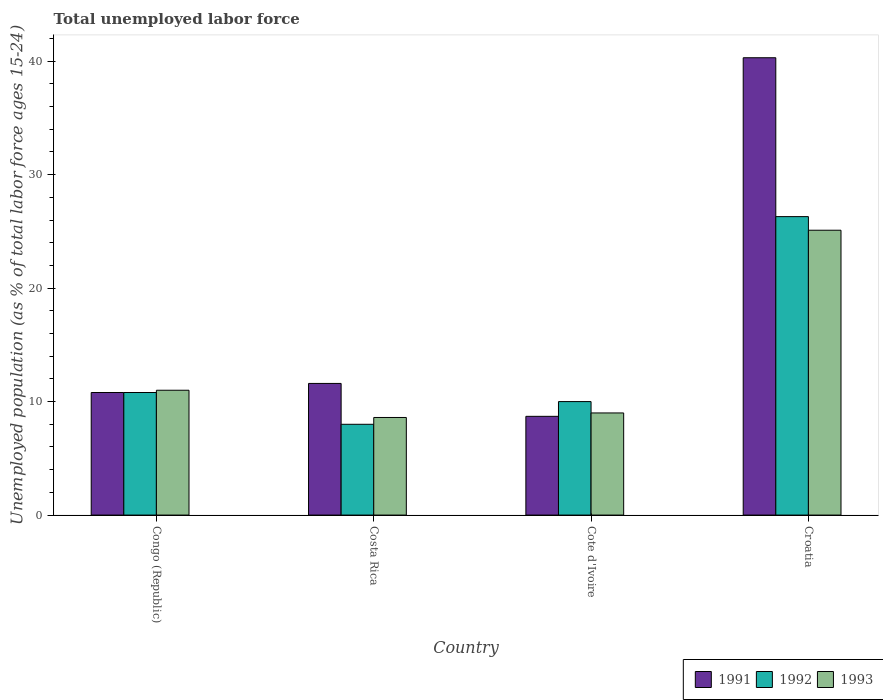How many different coloured bars are there?
Your answer should be compact. 3. Are the number of bars per tick equal to the number of legend labels?
Your response must be concise. Yes. Are the number of bars on each tick of the X-axis equal?
Ensure brevity in your answer.  Yes. How many bars are there on the 3rd tick from the left?
Your answer should be compact. 3. How many bars are there on the 4th tick from the right?
Offer a terse response. 3. What is the percentage of unemployed population in in 1993 in Costa Rica?
Your response must be concise. 8.6. Across all countries, what is the maximum percentage of unemployed population in in 1993?
Offer a very short reply. 25.1. Across all countries, what is the minimum percentage of unemployed population in in 1993?
Offer a terse response. 8.6. In which country was the percentage of unemployed population in in 1991 maximum?
Keep it short and to the point. Croatia. In which country was the percentage of unemployed population in in 1991 minimum?
Your answer should be very brief. Cote d'Ivoire. What is the total percentage of unemployed population in in 1991 in the graph?
Your answer should be very brief. 71.4. What is the difference between the percentage of unemployed population in in 1992 in Costa Rica and that in Croatia?
Your answer should be compact. -18.3. What is the difference between the percentage of unemployed population in in 1991 in Costa Rica and the percentage of unemployed population in in 1993 in Cote d'Ivoire?
Your answer should be compact. 2.6. What is the average percentage of unemployed population in in 1993 per country?
Your response must be concise. 13.43. What is the difference between the percentage of unemployed population in of/in 1992 and percentage of unemployed population in of/in 1991 in Croatia?
Provide a succinct answer. -14. What is the ratio of the percentage of unemployed population in in 1993 in Costa Rica to that in Croatia?
Give a very brief answer. 0.34. Is the percentage of unemployed population in in 1993 in Costa Rica less than that in Cote d'Ivoire?
Provide a succinct answer. Yes. What is the difference between the highest and the second highest percentage of unemployed population in in 1991?
Provide a short and direct response. 29.5. What is the difference between the highest and the lowest percentage of unemployed population in in 1991?
Your answer should be compact. 31.6. Is the sum of the percentage of unemployed population in in 1993 in Costa Rica and Cote d'Ivoire greater than the maximum percentage of unemployed population in in 1991 across all countries?
Your answer should be very brief. No. What does the 3rd bar from the right in Congo (Republic) represents?
Keep it short and to the point. 1991. Is it the case that in every country, the sum of the percentage of unemployed population in in 1993 and percentage of unemployed population in in 1992 is greater than the percentage of unemployed population in in 1991?
Make the answer very short. Yes. How many bars are there?
Your answer should be compact. 12. Are all the bars in the graph horizontal?
Your answer should be very brief. No. How many countries are there in the graph?
Your response must be concise. 4. What is the difference between two consecutive major ticks on the Y-axis?
Give a very brief answer. 10. Does the graph contain grids?
Your answer should be compact. No. How many legend labels are there?
Provide a short and direct response. 3. What is the title of the graph?
Your answer should be very brief. Total unemployed labor force. What is the label or title of the Y-axis?
Your response must be concise. Unemployed population (as % of total labor force ages 15-24). What is the Unemployed population (as % of total labor force ages 15-24) in 1991 in Congo (Republic)?
Keep it short and to the point. 10.8. What is the Unemployed population (as % of total labor force ages 15-24) in 1992 in Congo (Republic)?
Keep it short and to the point. 10.8. What is the Unemployed population (as % of total labor force ages 15-24) in 1991 in Costa Rica?
Your answer should be compact. 11.6. What is the Unemployed population (as % of total labor force ages 15-24) of 1993 in Costa Rica?
Your answer should be very brief. 8.6. What is the Unemployed population (as % of total labor force ages 15-24) of 1991 in Cote d'Ivoire?
Make the answer very short. 8.7. What is the Unemployed population (as % of total labor force ages 15-24) of 1992 in Cote d'Ivoire?
Your response must be concise. 10. What is the Unemployed population (as % of total labor force ages 15-24) in 1993 in Cote d'Ivoire?
Ensure brevity in your answer.  9. What is the Unemployed population (as % of total labor force ages 15-24) of 1991 in Croatia?
Your answer should be compact. 40.3. What is the Unemployed population (as % of total labor force ages 15-24) of 1992 in Croatia?
Ensure brevity in your answer.  26.3. What is the Unemployed population (as % of total labor force ages 15-24) in 1993 in Croatia?
Provide a short and direct response. 25.1. Across all countries, what is the maximum Unemployed population (as % of total labor force ages 15-24) in 1991?
Your answer should be very brief. 40.3. Across all countries, what is the maximum Unemployed population (as % of total labor force ages 15-24) of 1992?
Make the answer very short. 26.3. Across all countries, what is the maximum Unemployed population (as % of total labor force ages 15-24) of 1993?
Provide a short and direct response. 25.1. Across all countries, what is the minimum Unemployed population (as % of total labor force ages 15-24) of 1991?
Your answer should be very brief. 8.7. Across all countries, what is the minimum Unemployed population (as % of total labor force ages 15-24) in 1993?
Your answer should be very brief. 8.6. What is the total Unemployed population (as % of total labor force ages 15-24) of 1991 in the graph?
Keep it short and to the point. 71.4. What is the total Unemployed population (as % of total labor force ages 15-24) of 1992 in the graph?
Offer a terse response. 55.1. What is the total Unemployed population (as % of total labor force ages 15-24) in 1993 in the graph?
Keep it short and to the point. 53.7. What is the difference between the Unemployed population (as % of total labor force ages 15-24) of 1991 in Congo (Republic) and that in Costa Rica?
Keep it short and to the point. -0.8. What is the difference between the Unemployed population (as % of total labor force ages 15-24) in 1992 in Congo (Republic) and that in Costa Rica?
Your response must be concise. 2.8. What is the difference between the Unemployed population (as % of total labor force ages 15-24) of 1993 in Congo (Republic) and that in Costa Rica?
Give a very brief answer. 2.4. What is the difference between the Unemployed population (as % of total labor force ages 15-24) of 1991 in Congo (Republic) and that in Croatia?
Ensure brevity in your answer.  -29.5. What is the difference between the Unemployed population (as % of total labor force ages 15-24) in 1992 in Congo (Republic) and that in Croatia?
Provide a short and direct response. -15.5. What is the difference between the Unemployed population (as % of total labor force ages 15-24) in 1993 in Congo (Republic) and that in Croatia?
Provide a short and direct response. -14.1. What is the difference between the Unemployed population (as % of total labor force ages 15-24) in 1991 in Costa Rica and that in Cote d'Ivoire?
Offer a terse response. 2.9. What is the difference between the Unemployed population (as % of total labor force ages 15-24) in 1992 in Costa Rica and that in Cote d'Ivoire?
Your response must be concise. -2. What is the difference between the Unemployed population (as % of total labor force ages 15-24) of 1993 in Costa Rica and that in Cote d'Ivoire?
Give a very brief answer. -0.4. What is the difference between the Unemployed population (as % of total labor force ages 15-24) of 1991 in Costa Rica and that in Croatia?
Provide a short and direct response. -28.7. What is the difference between the Unemployed population (as % of total labor force ages 15-24) of 1992 in Costa Rica and that in Croatia?
Provide a succinct answer. -18.3. What is the difference between the Unemployed population (as % of total labor force ages 15-24) in 1993 in Costa Rica and that in Croatia?
Your response must be concise. -16.5. What is the difference between the Unemployed population (as % of total labor force ages 15-24) of 1991 in Cote d'Ivoire and that in Croatia?
Provide a succinct answer. -31.6. What is the difference between the Unemployed population (as % of total labor force ages 15-24) in 1992 in Cote d'Ivoire and that in Croatia?
Make the answer very short. -16.3. What is the difference between the Unemployed population (as % of total labor force ages 15-24) in 1993 in Cote d'Ivoire and that in Croatia?
Offer a terse response. -16.1. What is the difference between the Unemployed population (as % of total labor force ages 15-24) in 1992 in Congo (Republic) and the Unemployed population (as % of total labor force ages 15-24) in 1993 in Costa Rica?
Offer a very short reply. 2.2. What is the difference between the Unemployed population (as % of total labor force ages 15-24) in 1991 in Congo (Republic) and the Unemployed population (as % of total labor force ages 15-24) in 1993 in Cote d'Ivoire?
Provide a short and direct response. 1.8. What is the difference between the Unemployed population (as % of total labor force ages 15-24) in 1992 in Congo (Republic) and the Unemployed population (as % of total labor force ages 15-24) in 1993 in Cote d'Ivoire?
Your response must be concise. 1.8. What is the difference between the Unemployed population (as % of total labor force ages 15-24) of 1991 in Congo (Republic) and the Unemployed population (as % of total labor force ages 15-24) of 1992 in Croatia?
Ensure brevity in your answer.  -15.5. What is the difference between the Unemployed population (as % of total labor force ages 15-24) in 1991 in Congo (Republic) and the Unemployed population (as % of total labor force ages 15-24) in 1993 in Croatia?
Offer a very short reply. -14.3. What is the difference between the Unemployed population (as % of total labor force ages 15-24) in 1992 in Congo (Republic) and the Unemployed population (as % of total labor force ages 15-24) in 1993 in Croatia?
Provide a succinct answer. -14.3. What is the difference between the Unemployed population (as % of total labor force ages 15-24) of 1991 in Costa Rica and the Unemployed population (as % of total labor force ages 15-24) of 1992 in Croatia?
Ensure brevity in your answer.  -14.7. What is the difference between the Unemployed population (as % of total labor force ages 15-24) of 1992 in Costa Rica and the Unemployed population (as % of total labor force ages 15-24) of 1993 in Croatia?
Make the answer very short. -17.1. What is the difference between the Unemployed population (as % of total labor force ages 15-24) in 1991 in Cote d'Ivoire and the Unemployed population (as % of total labor force ages 15-24) in 1992 in Croatia?
Offer a very short reply. -17.6. What is the difference between the Unemployed population (as % of total labor force ages 15-24) of 1991 in Cote d'Ivoire and the Unemployed population (as % of total labor force ages 15-24) of 1993 in Croatia?
Give a very brief answer. -16.4. What is the difference between the Unemployed population (as % of total labor force ages 15-24) of 1992 in Cote d'Ivoire and the Unemployed population (as % of total labor force ages 15-24) of 1993 in Croatia?
Provide a short and direct response. -15.1. What is the average Unemployed population (as % of total labor force ages 15-24) of 1991 per country?
Your answer should be very brief. 17.85. What is the average Unemployed population (as % of total labor force ages 15-24) in 1992 per country?
Your answer should be compact. 13.78. What is the average Unemployed population (as % of total labor force ages 15-24) in 1993 per country?
Your answer should be compact. 13.43. What is the difference between the Unemployed population (as % of total labor force ages 15-24) in 1991 and Unemployed population (as % of total labor force ages 15-24) in 1993 in Congo (Republic)?
Offer a terse response. -0.2. What is the difference between the Unemployed population (as % of total labor force ages 15-24) of 1992 and Unemployed population (as % of total labor force ages 15-24) of 1993 in Congo (Republic)?
Keep it short and to the point. -0.2. What is the difference between the Unemployed population (as % of total labor force ages 15-24) in 1991 and Unemployed population (as % of total labor force ages 15-24) in 1992 in Costa Rica?
Your answer should be compact. 3.6. What is the difference between the Unemployed population (as % of total labor force ages 15-24) of 1992 and Unemployed population (as % of total labor force ages 15-24) of 1993 in Costa Rica?
Provide a succinct answer. -0.6. What is the difference between the Unemployed population (as % of total labor force ages 15-24) of 1991 and Unemployed population (as % of total labor force ages 15-24) of 1992 in Cote d'Ivoire?
Keep it short and to the point. -1.3. What is the ratio of the Unemployed population (as % of total labor force ages 15-24) of 1992 in Congo (Republic) to that in Costa Rica?
Offer a terse response. 1.35. What is the ratio of the Unemployed population (as % of total labor force ages 15-24) in 1993 in Congo (Republic) to that in Costa Rica?
Offer a very short reply. 1.28. What is the ratio of the Unemployed population (as % of total labor force ages 15-24) in 1991 in Congo (Republic) to that in Cote d'Ivoire?
Provide a succinct answer. 1.24. What is the ratio of the Unemployed population (as % of total labor force ages 15-24) in 1992 in Congo (Republic) to that in Cote d'Ivoire?
Keep it short and to the point. 1.08. What is the ratio of the Unemployed population (as % of total labor force ages 15-24) of 1993 in Congo (Republic) to that in Cote d'Ivoire?
Your answer should be very brief. 1.22. What is the ratio of the Unemployed population (as % of total labor force ages 15-24) of 1991 in Congo (Republic) to that in Croatia?
Offer a terse response. 0.27. What is the ratio of the Unemployed population (as % of total labor force ages 15-24) in 1992 in Congo (Republic) to that in Croatia?
Keep it short and to the point. 0.41. What is the ratio of the Unemployed population (as % of total labor force ages 15-24) in 1993 in Congo (Republic) to that in Croatia?
Offer a very short reply. 0.44. What is the ratio of the Unemployed population (as % of total labor force ages 15-24) of 1992 in Costa Rica to that in Cote d'Ivoire?
Provide a short and direct response. 0.8. What is the ratio of the Unemployed population (as % of total labor force ages 15-24) in 1993 in Costa Rica to that in Cote d'Ivoire?
Your answer should be very brief. 0.96. What is the ratio of the Unemployed population (as % of total labor force ages 15-24) of 1991 in Costa Rica to that in Croatia?
Your answer should be very brief. 0.29. What is the ratio of the Unemployed population (as % of total labor force ages 15-24) of 1992 in Costa Rica to that in Croatia?
Your response must be concise. 0.3. What is the ratio of the Unemployed population (as % of total labor force ages 15-24) of 1993 in Costa Rica to that in Croatia?
Your answer should be very brief. 0.34. What is the ratio of the Unemployed population (as % of total labor force ages 15-24) in 1991 in Cote d'Ivoire to that in Croatia?
Offer a terse response. 0.22. What is the ratio of the Unemployed population (as % of total labor force ages 15-24) in 1992 in Cote d'Ivoire to that in Croatia?
Your answer should be compact. 0.38. What is the ratio of the Unemployed population (as % of total labor force ages 15-24) in 1993 in Cote d'Ivoire to that in Croatia?
Your answer should be very brief. 0.36. What is the difference between the highest and the second highest Unemployed population (as % of total labor force ages 15-24) of 1991?
Your response must be concise. 28.7. What is the difference between the highest and the second highest Unemployed population (as % of total labor force ages 15-24) of 1992?
Your answer should be compact. 15.5. What is the difference between the highest and the lowest Unemployed population (as % of total labor force ages 15-24) in 1991?
Make the answer very short. 31.6. What is the difference between the highest and the lowest Unemployed population (as % of total labor force ages 15-24) of 1992?
Make the answer very short. 18.3. What is the difference between the highest and the lowest Unemployed population (as % of total labor force ages 15-24) of 1993?
Your answer should be very brief. 16.5. 